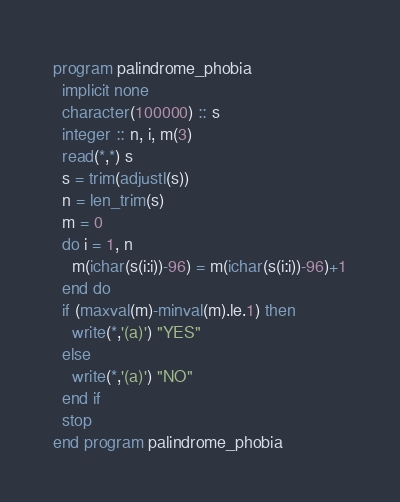Convert code to text. <code><loc_0><loc_0><loc_500><loc_500><_FORTRAN_>program palindrome_phobia
  implicit none
  character(100000) :: s
  integer :: n, i, m(3)
  read(*,*) s
  s = trim(adjustl(s))
  n = len_trim(s)
  m = 0
  do i = 1, n
    m(ichar(s(i:i))-96) = m(ichar(s(i:i))-96)+1
  end do
  if (maxval(m)-minval(m).le.1) then
    write(*,'(a)') "YES"
  else
    write(*,'(a)') "NO"
  end if
  stop
end program palindrome_phobia</code> 